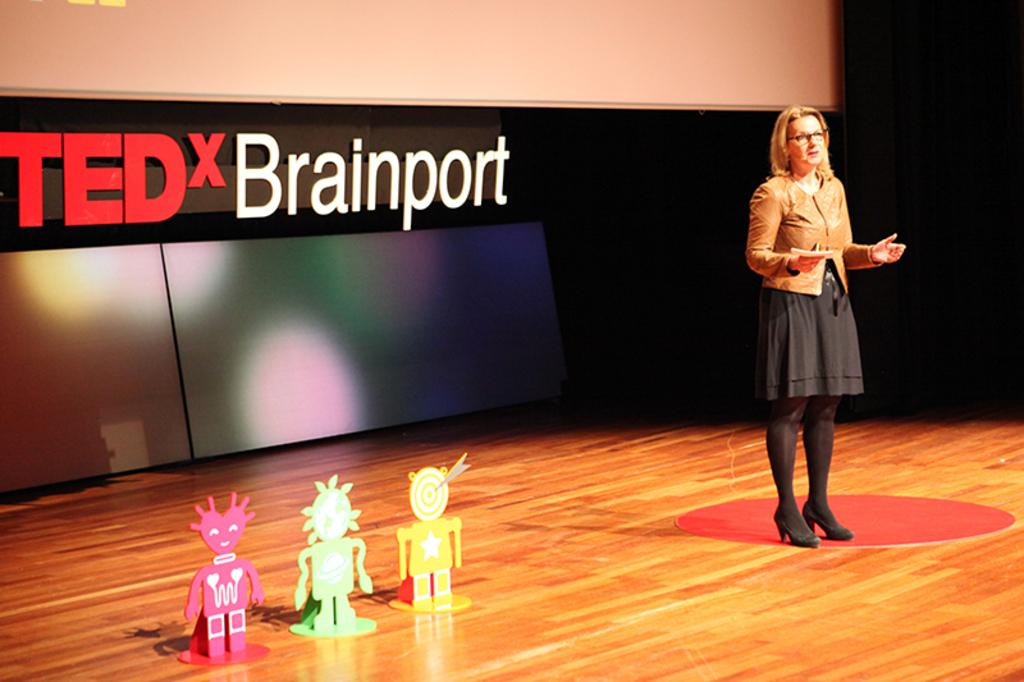What is the main subject of the image? The main subject of the image is a woman standing. What is the woman wearing in the image? The woman is wearing a jacket in the image. What can be seen on the stage in the image? There are 3 toys on the stage in the image. What is present behind the stage in the image? There is a banner behind the stage in the image. What advice does the woman give to the audience in the image? There is no indication in the image that the woman is giving advice to the audience. What type of ring is the woman wearing in the image? There is no ring visible on the woman in the image. 